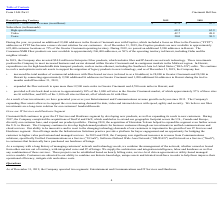Looking at Cincinnati Bell's financial data, please calculate: What proportion of the amount invested in Enterprise Fiber products is the 2019 revenue? Based on the calculation: 87.2/24, the result is 363.33 (percentage). This is based on the information: "Consumer / SMB Fiber Revenue (in millions): $ 87.2 $ 42.3 Fiber products are now available to approximately 246,400 addresses, or 50% of the operating territory in Hawaii, including Oahu and the neigh..." The key data points involved are: 24, 87.2. Also, can you calculate: What is the total number of subscribers in 2019? Based on the calculation: 68.2+42.7+30.0, the result is 140.9 (in thousands). This is based on the information: "Voice 30.0 30.3 High-speed internet 68.2 65.9 Video 42.7 48.8..." The key data points involved are: 30.0, 42.7, 68.2. Also, can you calculate: What is the percentage change in Hiah-speed internet Subscribers between 2018 to 2019? To answer this question, I need to perform calculations using the financial data. The calculation is: (68.2-65.9)/65.9, which equals 3.49 (percentage). This is based on the information: "High-speed internet 68.2 65.9 High-speed internet 68.2 65.9..." The key data points involved are: 65.9, 68.2. Also, can you calculate: What is the total revenue earned across 2018 to 2019? Based on the calculation: 87.2+42.3, the result is 129.5 (in millions). This is based on the information: "Consumer / SMB Fiber Revenue (in millions): $ 87.2 $ 42.3 sumer / SMB Fiber Revenue (in millions): $ 87.2 $ 42.3..." The key data points involved are: 42.3, 87.2. Also, When did the company start enjoying year on year  Entertainment and Communications revenue growth? According to the financial document, 2013. The relevant text states: "and Communications revenue growth each year since 2013. The Company's expanding fiber assets allow us to support the ever-increasing demand for data, vide..." Also, What is the fiber network expansion in Hawaii? According to the financial document, 4,700. The relevant text states: "than 12,500 route miles in Greater Cincinnati and 4,700 route miles in Hawaii; and..." Also, How many video subscribers are there in 2018? According to the financial document, 48.8 (in thousands). The relevant text states: "Video 42.7 48.8..." 